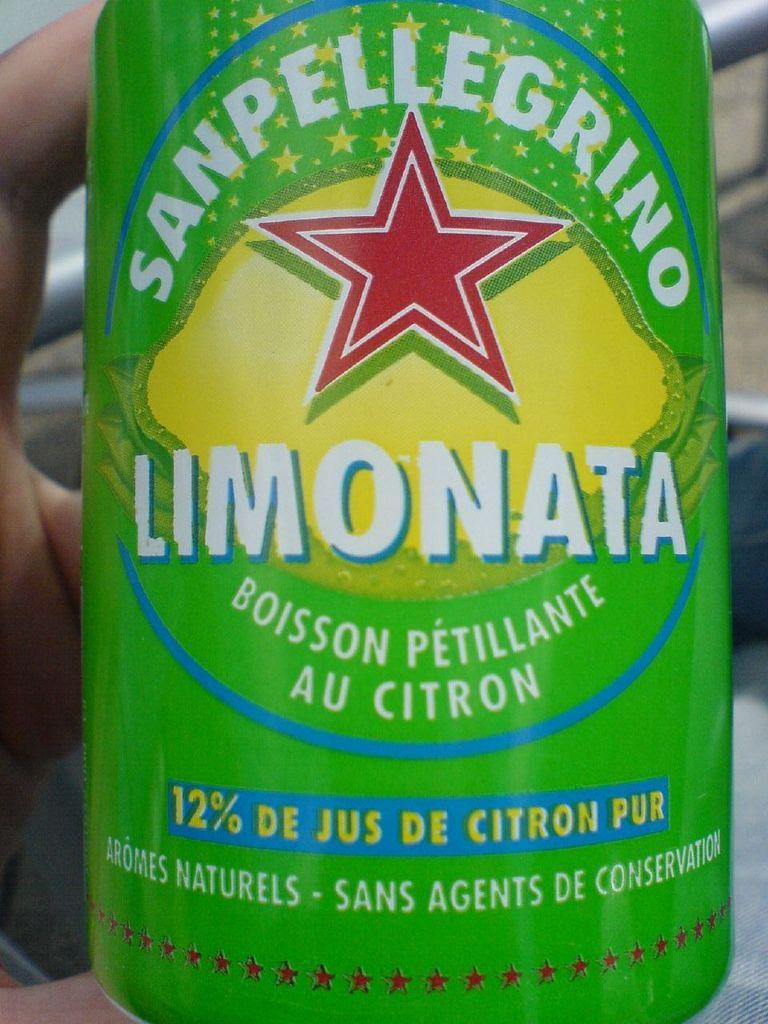<image>
Give a short and clear explanation of the subsequent image. A green can of San Pellegrino Limonata with a red star on it. 